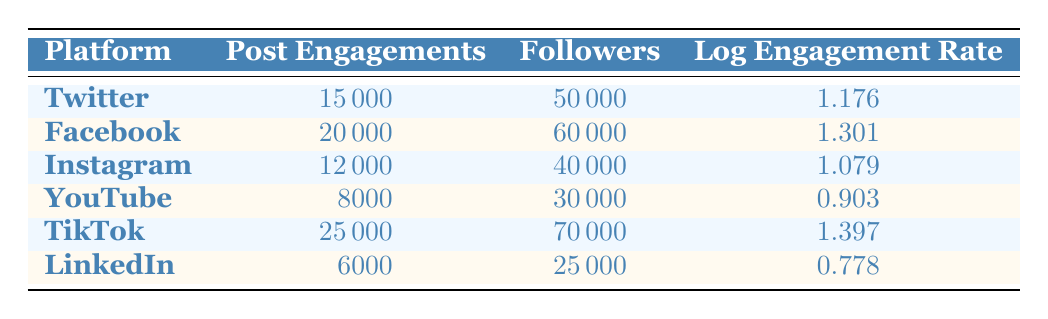What is the log engagement rate for TikTok? The log engagement rate for TikTok is directly listed in the table. By looking under the column labeled "Log Engagement Rate," the rate for TikTok is found to be 1.397.
Answer: 1.397 What is the highest number of post engagements among the platforms? To find the highest number of post engagements, we compare the values under the "Post Engagements" column. The maximum value is 25000 for TikTok.
Answer: 25000 Which platform has the lowest log engagement rate? By scanning the "Log Engagement Rate" column, we can identify that the lowest rate is 0.778, which corresponds to LinkedIn.
Answer: LinkedIn How many total followers do all platforms have combined? We sum the values in the "Followers" column: 50000 + 60000 + 40000 + 30000 + 70000 + 25000 = 280000.
Answer: 280000 Is the log engagement rate for Twitter greater than that of YouTube? We can compare the log engagement rates directly from the table. Twitter's log engagement rate is 1.176, and YouTube's is 0.903. Since 1.176 is greater than 0.903, the statement is true.
Answer: Yes What is the average number of post engagements across all platforms? To find the average, first sum the post engagements: 15000 + 20000 + 12000 + 8000 + 25000 + 6000 = 100000. Then divide by the number of platforms, which is 6: 100000 / 6 = 16666.67.
Answer: 16666.67 Does Facebook have more followers than both Twitter and Instagram combined? First, we find Twitter's and Instagram's follower counts: Twitter has 50000 and Instagram has 40000, which combine to 90000. Facebook has 60000 followers, which is not greater than 90000. Therefore, the statement is false.
Answer: No Which platform has more post engagements: Instagram or YouTube? The number of post engagements for Instagram is 12000, while for YouTube, it is 8000. Since 12000 is greater than 8000, Instagram has more engagements.
Answer: Instagram 